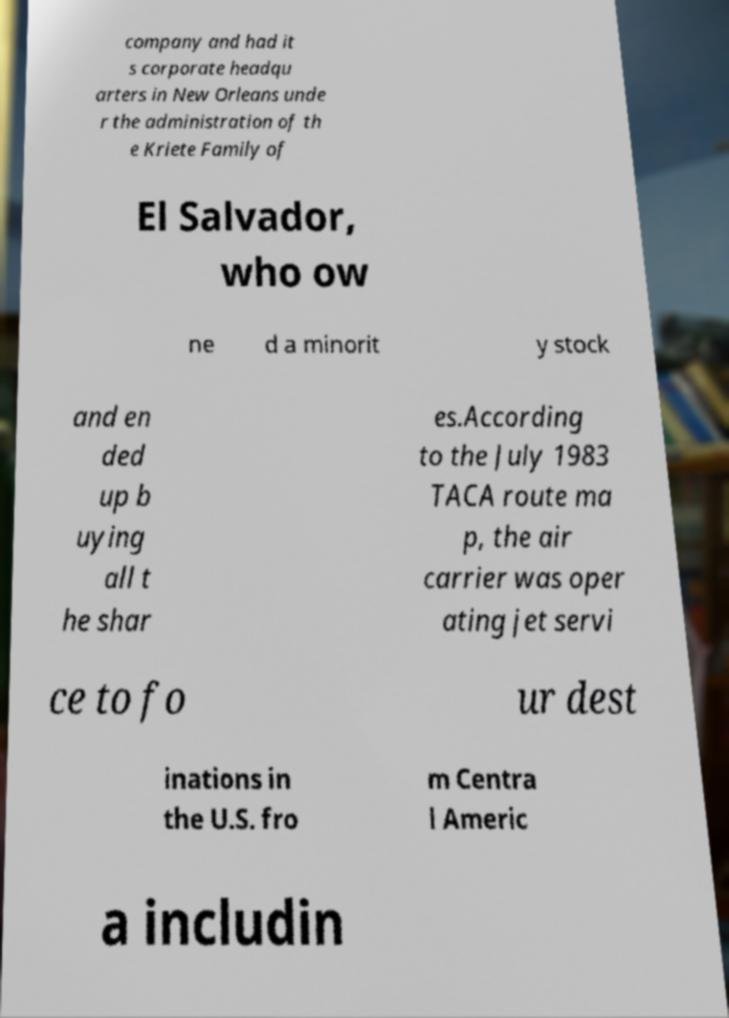Please identify and transcribe the text found in this image. company and had it s corporate headqu arters in New Orleans unde r the administration of th e Kriete Family of El Salvador, who ow ne d a minorit y stock and en ded up b uying all t he shar es.According to the July 1983 TACA route ma p, the air carrier was oper ating jet servi ce to fo ur dest inations in the U.S. fro m Centra l Americ a includin 